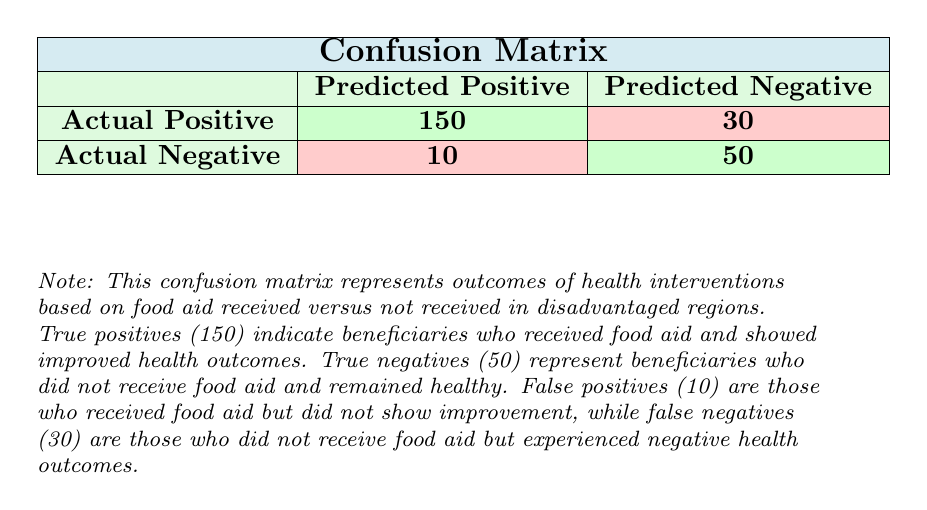What is the number of true positives? The table indicates that the number of true positives is represented in the cell where actual positive and predicted positive intersect, which is 150.
Answer: 150 How many beneficiaries received food aid but did not show improvement? The false positives represent beneficiaries who received food aid but did not show improvement, clearly indicated in the table as 10.
Answer: 10 What is the total number of actual negative cases? To find the total number of actual negative cases, we add the false positives (10) and true negatives (50), which gives us 10 + 50 = 60.
Answer: 60 If a beneficiary did not receive food aid, what is the probability they showed a negative health outcome? The probability of a negative health outcome for those who did not receive food aid is calculated by dividing the number of false negatives (30) by the total actual negatives (30 + 50 = 80). So, 30/80 = 0.375 or 37.5%.
Answer: 37.5% Are there more true positives or true negatives? Looking at the table, true positives (150) are greater than true negatives (50). This indicates a higher number of those who benefited positively from food aid.
Answer: Yes How many individuals experienced negative health outcomes from those who received food aid? Individuals who experienced negative health outcomes from those receiving food aid are represented by false positives, which is 10.
Answer: 10 What is the difference in numbers between true positives and false negatives? The difference is calculated by subtracting the false negatives (30) from the true positives (150), which results in 150 - 30 = 120.
Answer: 120 What percentage of beneficiaries who received food aid actually showed improved health outcomes? To find the percentage, divide the true positives (150) by the total number of beneficiaries who received food aid (true positives + false positives = 150 + 10 = 160), which results in (150/160)*100 = 93.75%.
Answer: 93.75% Did more beneficiaries not receive food aid compared to those who received it? The total number of beneficiaries who did not receive food aid (true negatives + false negatives = 50 + 30 = 80) is greater than those who received food aid (true positives + false positives = 150 + 10 = 160).
Answer: No 